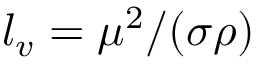<formula> <loc_0><loc_0><loc_500><loc_500>l _ { v } = \mu ^ { 2 } / ( \sigma \rho )</formula> 